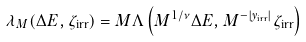Convert formula to latex. <formula><loc_0><loc_0><loc_500><loc_500>\lambda _ { M } ( \Delta E , \zeta _ { \text {irr} } ) = M \Lambda \left ( M ^ { 1 / \nu } \Delta E , M ^ { - | y _ { \text {irr} } | } \zeta _ { \text {irr} } \right )</formula> 